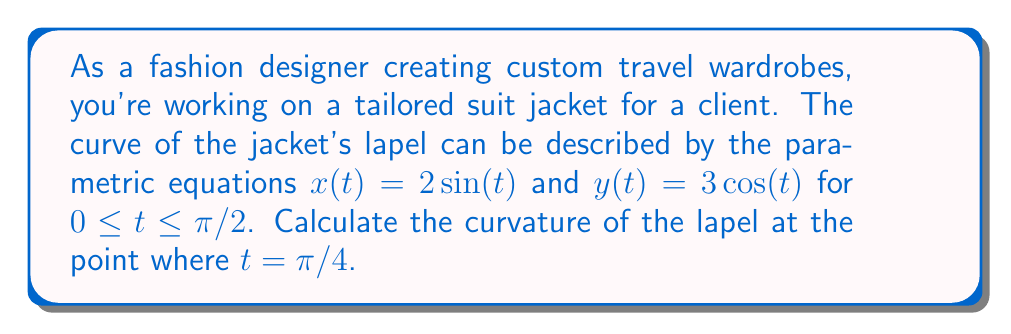Could you help me with this problem? To find the curvature of the lapel, we'll use the formula for curvature of a curve given in parametric form:

$$\kappa = \frac{|x'y'' - y'x''|}{(x'^2 + y'^2)^{3/2}}$$

Let's follow these steps:

1. Find $x'(t)$, $y'(t)$, $x''(t)$, and $y''(t)$:
   $x'(t) = 2\cos(t)$
   $y'(t) = -3\sin(t)$
   $x''(t) = -2\sin(t)$
   $y''(t) = -3\cos(t)$

2. Evaluate these at $t = \pi/4$:
   $x'(\pi/4) = 2\cos(\pi/4) = \sqrt{2}$
   $y'(\pi/4) = -3\sin(\pi/4) = -3\sqrt{2}/2$
   $x''(\pi/4) = -2\sin(\pi/4) = -\sqrt{2}$
   $y''(\pi/4) = -3\cos(\pi/4) = -3\sqrt{2}/2$

3. Calculate the numerator of the curvature formula:
   $|x'y'' - y'x''| = |(\sqrt{2})(-3\sqrt{2}/2) - (-3\sqrt{2}/2)(-\sqrt{2})|$
                    $= |-3/2 + 3/2| = 0$

4. Calculate the denominator:
   $(x'^2 + y'^2)^{3/2} = ((\sqrt{2})^2 + (-3\sqrt{2}/2)^2)^{3/2}$
                        $= (2 + 9/2)^{3/2} = (13/2)^{3/2}$

5. Divide the numerator by the denominator:
   $\kappa = \frac{0}{(13/2)^{3/2}} = 0$

Therefore, the curvature of the lapel at $t = \pi/4$ is 0.
Answer: The curvature of the lapel at $t = \pi/4$ is 0. 